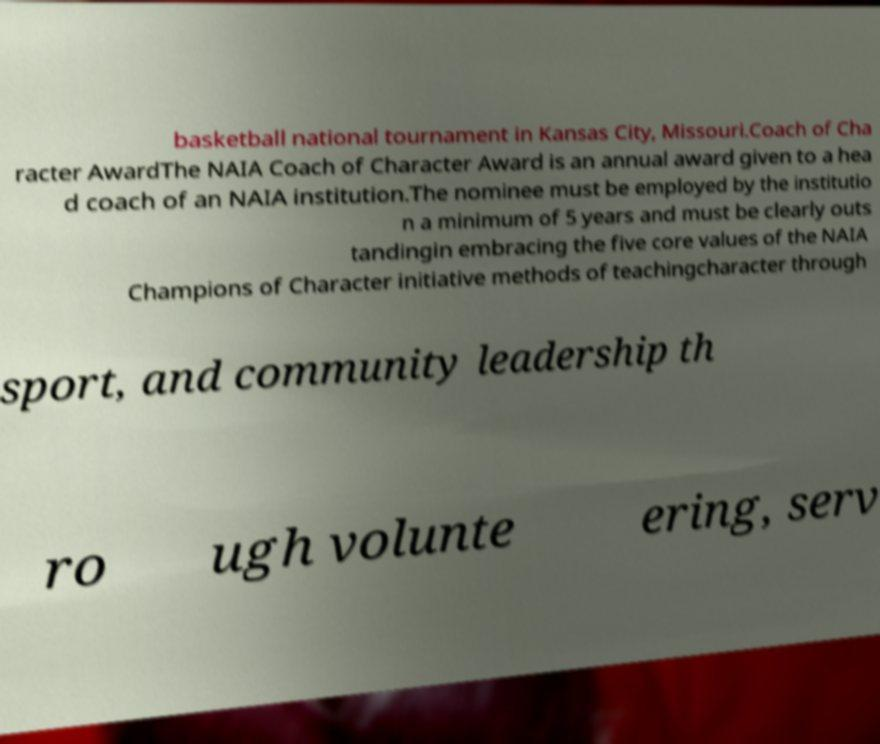For documentation purposes, I need the text within this image transcribed. Could you provide that? basketball national tournament in Kansas City, Missouri.Coach of Cha racter AwardThe NAIA Coach of Character Award is an annual award given to a hea d coach of an NAIA institution.The nominee must be employed by the institutio n a minimum of 5 years and must be clearly outs tandingin embracing the five core values of the NAIA Champions of Character initiative methods of teachingcharacter through sport, and community leadership th ro ugh volunte ering, serv 